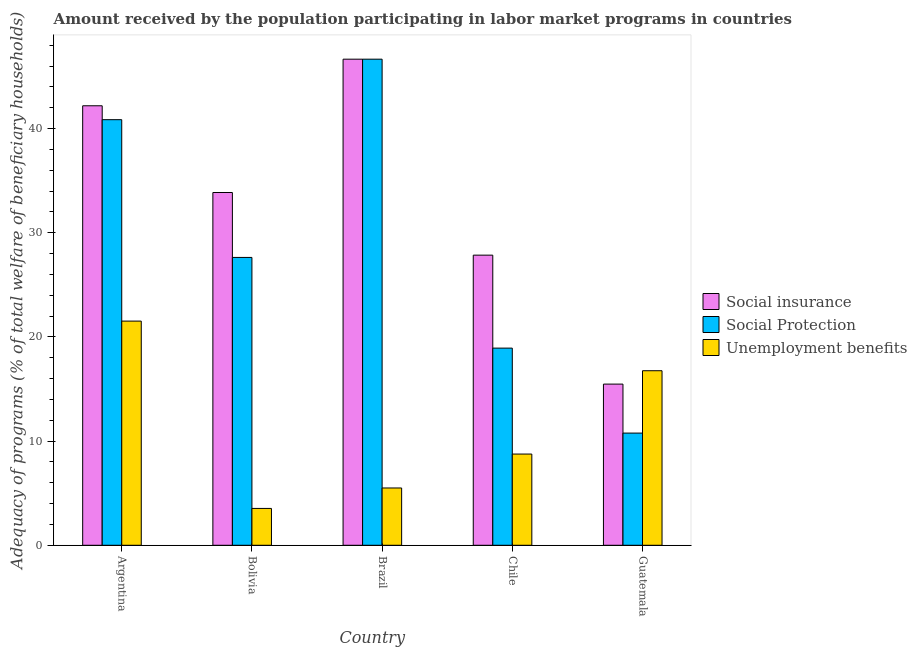How many different coloured bars are there?
Your answer should be compact. 3. How many groups of bars are there?
Your answer should be very brief. 5. Are the number of bars per tick equal to the number of legend labels?
Give a very brief answer. Yes. How many bars are there on the 2nd tick from the left?
Your answer should be very brief. 3. How many bars are there on the 3rd tick from the right?
Offer a terse response. 3. What is the label of the 4th group of bars from the left?
Offer a terse response. Chile. What is the amount received by the population participating in unemployment benefits programs in Bolivia?
Offer a terse response. 3.54. Across all countries, what is the maximum amount received by the population participating in unemployment benefits programs?
Provide a succinct answer. 21.52. Across all countries, what is the minimum amount received by the population participating in social insurance programs?
Your answer should be very brief. 15.47. In which country was the amount received by the population participating in social protection programs maximum?
Your response must be concise. Brazil. In which country was the amount received by the population participating in social protection programs minimum?
Your answer should be compact. Guatemala. What is the total amount received by the population participating in social protection programs in the graph?
Keep it short and to the point. 144.86. What is the difference between the amount received by the population participating in social insurance programs in Bolivia and that in Brazil?
Provide a short and direct response. -12.8. What is the difference between the amount received by the population participating in social protection programs in Brazil and the amount received by the population participating in unemployment benefits programs in Guatemala?
Offer a very short reply. 29.91. What is the average amount received by the population participating in social protection programs per country?
Provide a succinct answer. 28.97. What is the difference between the amount received by the population participating in social insurance programs and amount received by the population participating in social protection programs in Guatemala?
Give a very brief answer. 4.7. In how many countries, is the amount received by the population participating in unemployment benefits programs greater than 10 %?
Make the answer very short. 2. What is the ratio of the amount received by the population participating in social protection programs in Brazil to that in Chile?
Provide a short and direct response. 2.47. Is the difference between the amount received by the population participating in unemployment benefits programs in Chile and Guatemala greater than the difference between the amount received by the population participating in social insurance programs in Chile and Guatemala?
Give a very brief answer. No. What is the difference between the highest and the second highest amount received by the population participating in social insurance programs?
Your answer should be compact. 4.47. What is the difference between the highest and the lowest amount received by the population participating in social protection programs?
Provide a succinct answer. 35.9. Is the sum of the amount received by the population participating in unemployment benefits programs in Brazil and Chile greater than the maximum amount received by the population participating in social insurance programs across all countries?
Provide a succinct answer. No. What does the 3rd bar from the left in Guatemala represents?
Make the answer very short. Unemployment benefits. What does the 2nd bar from the right in Bolivia represents?
Your answer should be compact. Social Protection. Is it the case that in every country, the sum of the amount received by the population participating in social insurance programs and amount received by the population participating in social protection programs is greater than the amount received by the population participating in unemployment benefits programs?
Your response must be concise. Yes. Are all the bars in the graph horizontal?
Offer a terse response. No. What is the difference between two consecutive major ticks on the Y-axis?
Offer a very short reply. 10. Does the graph contain any zero values?
Offer a very short reply. No. How are the legend labels stacked?
Make the answer very short. Vertical. What is the title of the graph?
Offer a very short reply. Amount received by the population participating in labor market programs in countries. What is the label or title of the Y-axis?
Your response must be concise. Adequacy of programs (% of total welfare of beneficiary households). What is the Adequacy of programs (% of total welfare of beneficiary households) in Social insurance in Argentina?
Your answer should be very brief. 42.2. What is the Adequacy of programs (% of total welfare of beneficiary households) of Social Protection in Argentina?
Give a very brief answer. 40.86. What is the Adequacy of programs (% of total welfare of beneficiary households) in Unemployment benefits in Argentina?
Provide a succinct answer. 21.52. What is the Adequacy of programs (% of total welfare of beneficiary households) in Social insurance in Bolivia?
Provide a short and direct response. 33.87. What is the Adequacy of programs (% of total welfare of beneficiary households) of Social Protection in Bolivia?
Your answer should be compact. 27.63. What is the Adequacy of programs (% of total welfare of beneficiary households) of Unemployment benefits in Bolivia?
Your answer should be compact. 3.54. What is the Adequacy of programs (% of total welfare of beneficiary households) of Social insurance in Brazil?
Give a very brief answer. 46.67. What is the Adequacy of programs (% of total welfare of beneficiary households) in Social Protection in Brazil?
Give a very brief answer. 46.67. What is the Adequacy of programs (% of total welfare of beneficiary households) in Unemployment benefits in Brazil?
Your response must be concise. 5.5. What is the Adequacy of programs (% of total welfare of beneficiary households) of Social insurance in Chile?
Your answer should be very brief. 27.85. What is the Adequacy of programs (% of total welfare of beneficiary households) in Social Protection in Chile?
Keep it short and to the point. 18.93. What is the Adequacy of programs (% of total welfare of beneficiary households) of Unemployment benefits in Chile?
Your answer should be very brief. 8.76. What is the Adequacy of programs (% of total welfare of beneficiary households) in Social insurance in Guatemala?
Your answer should be very brief. 15.47. What is the Adequacy of programs (% of total welfare of beneficiary households) in Social Protection in Guatemala?
Keep it short and to the point. 10.77. What is the Adequacy of programs (% of total welfare of beneficiary households) of Unemployment benefits in Guatemala?
Keep it short and to the point. 16.76. Across all countries, what is the maximum Adequacy of programs (% of total welfare of beneficiary households) of Social insurance?
Offer a very short reply. 46.67. Across all countries, what is the maximum Adequacy of programs (% of total welfare of beneficiary households) of Social Protection?
Offer a terse response. 46.67. Across all countries, what is the maximum Adequacy of programs (% of total welfare of beneficiary households) in Unemployment benefits?
Give a very brief answer. 21.52. Across all countries, what is the minimum Adequacy of programs (% of total welfare of beneficiary households) of Social insurance?
Keep it short and to the point. 15.47. Across all countries, what is the minimum Adequacy of programs (% of total welfare of beneficiary households) of Social Protection?
Your answer should be compact. 10.77. Across all countries, what is the minimum Adequacy of programs (% of total welfare of beneficiary households) in Unemployment benefits?
Your response must be concise. 3.54. What is the total Adequacy of programs (% of total welfare of beneficiary households) in Social insurance in the graph?
Ensure brevity in your answer.  166.06. What is the total Adequacy of programs (% of total welfare of beneficiary households) in Social Protection in the graph?
Your answer should be compact. 144.86. What is the total Adequacy of programs (% of total welfare of beneficiary households) in Unemployment benefits in the graph?
Make the answer very short. 56.07. What is the difference between the Adequacy of programs (% of total welfare of beneficiary households) in Social insurance in Argentina and that in Bolivia?
Ensure brevity in your answer.  8.33. What is the difference between the Adequacy of programs (% of total welfare of beneficiary households) in Social Protection in Argentina and that in Bolivia?
Ensure brevity in your answer.  13.23. What is the difference between the Adequacy of programs (% of total welfare of beneficiary households) of Unemployment benefits in Argentina and that in Bolivia?
Give a very brief answer. 17.98. What is the difference between the Adequacy of programs (% of total welfare of beneficiary households) in Social insurance in Argentina and that in Brazil?
Provide a short and direct response. -4.47. What is the difference between the Adequacy of programs (% of total welfare of beneficiary households) of Social Protection in Argentina and that in Brazil?
Give a very brief answer. -5.81. What is the difference between the Adequacy of programs (% of total welfare of beneficiary households) in Unemployment benefits in Argentina and that in Brazil?
Provide a succinct answer. 16.02. What is the difference between the Adequacy of programs (% of total welfare of beneficiary households) of Social insurance in Argentina and that in Chile?
Give a very brief answer. 14.34. What is the difference between the Adequacy of programs (% of total welfare of beneficiary households) in Social Protection in Argentina and that in Chile?
Keep it short and to the point. 21.93. What is the difference between the Adequacy of programs (% of total welfare of beneficiary households) in Unemployment benefits in Argentina and that in Chile?
Keep it short and to the point. 12.76. What is the difference between the Adequacy of programs (% of total welfare of beneficiary households) of Social insurance in Argentina and that in Guatemala?
Offer a very short reply. 26.72. What is the difference between the Adequacy of programs (% of total welfare of beneficiary households) of Social Protection in Argentina and that in Guatemala?
Provide a short and direct response. 30.09. What is the difference between the Adequacy of programs (% of total welfare of beneficiary households) of Unemployment benefits in Argentina and that in Guatemala?
Ensure brevity in your answer.  4.76. What is the difference between the Adequacy of programs (% of total welfare of beneficiary households) in Social insurance in Bolivia and that in Brazil?
Keep it short and to the point. -12.8. What is the difference between the Adequacy of programs (% of total welfare of beneficiary households) in Social Protection in Bolivia and that in Brazil?
Your response must be concise. -19.03. What is the difference between the Adequacy of programs (% of total welfare of beneficiary households) of Unemployment benefits in Bolivia and that in Brazil?
Keep it short and to the point. -1.96. What is the difference between the Adequacy of programs (% of total welfare of beneficiary households) in Social insurance in Bolivia and that in Chile?
Keep it short and to the point. 6.01. What is the difference between the Adequacy of programs (% of total welfare of beneficiary households) of Social Protection in Bolivia and that in Chile?
Make the answer very short. 8.71. What is the difference between the Adequacy of programs (% of total welfare of beneficiary households) of Unemployment benefits in Bolivia and that in Chile?
Keep it short and to the point. -5.22. What is the difference between the Adequacy of programs (% of total welfare of beneficiary households) in Social insurance in Bolivia and that in Guatemala?
Provide a succinct answer. 18.39. What is the difference between the Adequacy of programs (% of total welfare of beneficiary households) in Social Protection in Bolivia and that in Guatemala?
Ensure brevity in your answer.  16.86. What is the difference between the Adequacy of programs (% of total welfare of beneficiary households) in Unemployment benefits in Bolivia and that in Guatemala?
Ensure brevity in your answer.  -13.22. What is the difference between the Adequacy of programs (% of total welfare of beneficiary households) of Social insurance in Brazil and that in Chile?
Your response must be concise. 18.81. What is the difference between the Adequacy of programs (% of total welfare of beneficiary households) of Social Protection in Brazil and that in Chile?
Provide a succinct answer. 27.74. What is the difference between the Adequacy of programs (% of total welfare of beneficiary households) of Unemployment benefits in Brazil and that in Chile?
Provide a short and direct response. -3.26. What is the difference between the Adequacy of programs (% of total welfare of beneficiary households) of Social insurance in Brazil and that in Guatemala?
Offer a terse response. 31.19. What is the difference between the Adequacy of programs (% of total welfare of beneficiary households) of Social Protection in Brazil and that in Guatemala?
Give a very brief answer. 35.9. What is the difference between the Adequacy of programs (% of total welfare of beneficiary households) of Unemployment benefits in Brazil and that in Guatemala?
Your answer should be compact. -11.26. What is the difference between the Adequacy of programs (% of total welfare of beneficiary households) of Social insurance in Chile and that in Guatemala?
Ensure brevity in your answer.  12.38. What is the difference between the Adequacy of programs (% of total welfare of beneficiary households) in Social Protection in Chile and that in Guatemala?
Provide a short and direct response. 8.16. What is the difference between the Adequacy of programs (% of total welfare of beneficiary households) of Unemployment benefits in Chile and that in Guatemala?
Give a very brief answer. -8. What is the difference between the Adequacy of programs (% of total welfare of beneficiary households) in Social insurance in Argentina and the Adequacy of programs (% of total welfare of beneficiary households) in Social Protection in Bolivia?
Your answer should be very brief. 14.56. What is the difference between the Adequacy of programs (% of total welfare of beneficiary households) in Social insurance in Argentina and the Adequacy of programs (% of total welfare of beneficiary households) in Unemployment benefits in Bolivia?
Give a very brief answer. 38.66. What is the difference between the Adequacy of programs (% of total welfare of beneficiary households) of Social Protection in Argentina and the Adequacy of programs (% of total welfare of beneficiary households) of Unemployment benefits in Bolivia?
Offer a terse response. 37.32. What is the difference between the Adequacy of programs (% of total welfare of beneficiary households) of Social insurance in Argentina and the Adequacy of programs (% of total welfare of beneficiary households) of Social Protection in Brazil?
Your response must be concise. -4.47. What is the difference between the Adequacy of programs (% of total welfare of beneficiary households) of Social insurance in Argentina and the Adequacy of programs (% of total welfare of beneficiary households) of Unemployment benefits in Brazil?
Keep it short and to the point. 36.69. What is the difference between the Adequacy of programs (% of total welfare of beneficiary households) in Social Protection in Argentina and the Adequacy of programs (% of total welfare of beneficiary households) in Unemployment benefits in Brazil?
Give a very brief answer. 35.36. What is the difference between the Adequacy of programs (% of total welfare of beneficiary households) in Social insurance in Argentina and the Adequacy of programs (% of total welfare of beneficiary households) in Social Protection in Chile?
Offer a terse response. 23.27. What is the difference between the Adequacy of programs (% of total welfare of beneficiary households) in Social insurance in Argentina and the Adequacy of programs (% of total welfare of beneficiary households) in Unemployment benefits in Chile?
Provide a short and direct response. 33.44. What is the difference between the Adequacy of programs (% of total welfare of beneficiary households) in Social Protection in Argentina and the Adequacy of programs (% of total welfare of beneficiary households) in Unemployment benefits in Chile?
Offer a very short reply. 32.1. What is the difference between the Adequacy of programs (% of total welfare of beneficiary households) of Social insurance in Argentina and the Adequacy of programs (% of total welfare of beneficiary households) of Social Protection in Guatemala?
Keep it short and to the point. 31.42. What is the difference between the Adequacy of programs (% of total welfare of beneficiary households) of Social insurance in Argentina and the Adequacy of programs (% of total welfare of beneficiary households) of Unemployment benefits in Guatemala?
Make the answer very short. 25.44. What is the difference between the Adequacy of programs (% of total welfare of beneficiary households) of Social Protection in Argentina and the Adequacy of programs (% of total welfare of beneficiary households) of Unemployment benefits in Guatemala?
Provide a short and direct response. 24.1. What is the difference between the Adequacy of programs (% of total welfare of beneficiary households) in Social insurance in Bolivia and the Adequacy of programs (% of total welfare of beneficiary households) in Social Protection in Brazil?
Ensure brevity in your answer.  -12.8. What is the difference between the Adequacy of programs (% of total welfare of beneficiary households) in Social insurance in Bolivia and the Adequacy of programs (% of total welfare of beneficiary households) in Unemployment benefits in Brazil?
Make the answer very short. 28.37. What is the difference between the Adequacy of programs (% of total welfare of beneficiary households) of Social Protection in Bolivia and the Adequacy of programs (% of total welfare of beneficiary households) of Unemployment benefits in Brazil?
Offer a very short reply. 22.13. What is the difference between the Adequacy of programs (% of total welfare of beneficiary households) in Social insurance in Bolivia and the Adequacy of programs (% of total welfare of beneficiary households) in Social Protection in Chile?
Keep it short and to the point. 14.94. What is the difference between the Adequacy of programs (% of total welfare of beneficiary households) of Social insurance in Bolivia and the Adequacy of programs (% of total welfare of beneficiary households) of Unemployment benefits in Chile?
Your answer should be compact. 25.11. What is the difference between the Adequacy of programs (% of total welfare of beneficiary households) of Social Protection in Bolivia and the Adequacy of programs (% of total welfare of beneficiary households) of Unemployment benefits in Chile?
Make the answer very short. 18.88. What is the difference between the Adequacy of programs (% of total welfare of beneficiary households) in Social insurance in Bolivia and the Adequacy of programs (% of total welfare of beneficiary households) in Social Protection in Guatemala?
Provide a succinct answer. 23.1. What is the difference between the Adequacy of programs (% of total welfare of beneficiary households) in Social insurance in Bolivia and the Adequacy of programs (% of total welfare of beneficiary households) in Unemployment benefits in Guatemala?
Keep it short and to the point. 17.11. What is the difference between the Adequacy of programs (% of total welfare of beneficiary households) of Social Protection in Bolivia and the Adequacy of programs (% of total welfare of beneficiary households) of Unemployment benefits in Guatemala?
Make the answer very short. 10.88. What is the difference between the Adequacy of programs (% of total welfare of beneficiary households) of Social insurance in Brazil and the Adequacy of programs (% of total welfare of beneficiary households) of Social Protection in Chile?
Provide a succinct answer. 27.74. What is the difference between the Adequacy of programs (% of total welfare of beneficiary households) in Social insurance in Brazil and the Adequacy of programs (% of total welfare of beneficiary households) in Unemployment benefits in Chile?
Your answer should be compact. 37.91. What is the difference between the Adequacy of programs (% of total welfare of beneficiary households) of Social Protection in Brazil and the Adequacy of programs (% of total welfare of beneficiary households) of Unemployment benefits in Chile?
Give a very brief answer. 37.91. What is the difference between the Adequacy of programs (% of total welfare of beneficiary households) in Social insurance in Brazil and the Adequacy of programs (% of total welfare of beneficiary households) in Social Protection in Guatemala?
Ensure brevity in your answer.  35.9. What is the difference between the Adequacy of programs (% of total welfare of beneficiary households) of Social insurance in Brazil and the Adequacy of programs (% of total welfare of beneficiary households) of Unemployment benefits in Guatemala?
Offer a very short reply. 29.91. What is the difference between the Adequacy of programs (% of total welfare of beneficiary households) of Social Protection in Brazil and the Adequacy of programs (% of total welfare of beneficiary households) of Unemployment benefits in Guatemala?
Your answer should be very brief. 29.91. What is the difference between the Adequacy of programs (% of total welfare of beneficiary households) in Social insurance in Chile and the Adequacy of programs (% of total welfare of beneficiary households) in Social Protection in Guatemala?
Make the answer very short. 17.08. What is the difference between the Adequacy of programs (% of total welfare of beneficiary households) in Social insurance in Chile and the Adequacy of programs (% of total welfare of beneficiary households) in Unemployment benefits in Guatemala?
Provide a short and direct response. 11.1. What is the difference between the Adequacy of programs (% of total welfare of beneficiary households) of Social Protection in Chile and the Adequacy of programs (% of total welfare of beneficiary households) of Unemployment benefits in Guatemala?
Ensure brevity in your answer.  2.17. What is the average Adequacy of programs (% of total welfare of beneficiary households) in Social insurance per country?
Give a very brief answer. 33.21. What is the average Adequacy of programs (% of total welfare of beneficiary households) of Social Protection per country?
Provide a succinct answer. 28.97. What is the average Adequacy of programs (% of total welfare of beneficiary households) of Unemployment benefits per country?
Offer a very short reply. 11.21. What is the difference between the Adequacy of programs (% of total welfare of beneficiary households) in Social insurance and Adequacy of programs (% of total welfare of beneficiary households) in Social Protection in Argentina?
Offer a terse response. 1.33. What is the difference between the Adequacy of programs (% of total welfare of beneficiary households) of Social insurance and Adequacy of programs (% of total welfare of beneficiary households) of Unemployment benefits in Argentina?
Offer a terse response. 20.67. What is the difference between the Adequacy of programs (% of total welfare of beneficiary households) in Social Protection and Adequacy of programs (% of total welfare of beneficiary households) in Unemployment benefits in Argentina?
Your response must be concise. 19.34. What is the difference between the Adequacy of programs (% of total welfare of beneficiary households) in Social insurance and Adequacy of programs (% of total welfare of beneficiary households) in Social Protection in Bolivia?
Keep it short and to the point. 6.23. What is the difference between the Adequacy of programs (% of total welfare of beneficiary households) in Social insurance and Adequacy of programs (% of total welfare of beneficiary households) in Unemployment benefits in Bolivia?
Give a very brief answer. 30.33. What is the difference between the Adequacy of programs (% of total welfare of beneficiary households) in Social Protection and Adequacy of programs (% of total welfare of beneficiary households) in Unemployment benefits in Bolivia?
Keep it short and to the point. 24.1. What is the difference between the Adequacy of programs (% of total welfare of beneficiary households) in Social insurance and Adequacy of programs (% of total welfare of beneficiary households) in Unemployment benefits in Brazil?
Your response must be concise. 41.17. What is the difference between the Adequacy of programs (% of total welfare of beneficiary households) in Social Protection and Adequacy of programs (% of total welfare of beneficiary households) in Unemployment benefits in Brazil?
Your answer should be very brief. 41.17. What is the difference between the Adequacy of programs (% of total welfare of beneficiary households) of Social insurance and Adequacy of programs (% of total welfare of beneficiary households) of Social Protection in Chile?
Your answer should be compact. 8.93. What is the difference between the Adequacy of programs (% of total welfare of beneficiary households) of Social insurance and Adequacy of programs (% of total welfare of beneficiary households) of Unemployment benefits in Chile?
Provide a short and direct response. 19.1. What is the difference between the Adequacy of programs (% of total welfare of beneficiary households) of Social Protection and Adequacy of programs (% of total welfare of beneficiary households) of Unemployment benefits in Chile?
Give a very brief answer. 10.17. What is the difference between the Adequacy of programs (% of total welfare of beneficiary households) in Social insurance and Adequacy of programs (% of total welfare of beneficiary households) in Social Protection in Guatemala?
Your response must be concise. 4.7. What is the difference between the Adequacy of programs (% of total welfare of beneficiary households) of Social insurance and Adequacy of programs (% of total welfare of beneficiary households) of Unemployment benefits in Guatemala?
Make the answer very short. -1.28. What is the difference between the Adequacy of programs (% of total welfare of beneficiary households) in Social Protection and Adequacy of programs (% of total welfare of beneficiary households) in Unemployment benefits in Guatemala?
Provide a short and direct response. -5.99. What is the ratio of the Adequacy of programs (% of total welfare of beneficiary households) in Social insurance in Argentina to that in Bolivia?
Offer a terse response. 1.25. What is the ratio of the Adequacy of programs (% of total welfare of beneficiary households) of Social Protection in Argentina to that in Bolivia?
Provide a short and direct response. 1.48. What is the ratio of the Adequacy of programs (% of total welfare of beneficiary households) in Unemployment benefits in Argentina to that in Bolivia?
Provide a short and direct response. 6.08. What is the ratio of the Adequacy of programs (% of total welfare of beneficiary households) of Social insurance in Argentina to that in Brazil?
Provide a short and direct response. 0.9. What is the ratio of the Adequacy of programs (% of total welfare of beneficiary households) of Social Protection in Argentina to that in Brazil?
Keep it short and to the point. 0.88. What is the ratio of the Adequacy of programs (% of total welfare of beneficiary households) in Unemployment benefits in Argentina to that in Brazil?
Provide a short and direct response. 3.91. What is the ratio of the Adequacy of programs (% of total welfare of beneficiary households) of Social insurance in Argentina to that in Chile?
Your response must be concise. 1.51. What is the ratio of the Adequacy of programs (% of total welfare of beneficiary households) in Social Protection in Argentina to that in Chile?
Provide a succinct answer. 2.16. What is the ratio of the Adequacy of programs (% of total welfare of beneficiary households) in Unemployment benefits in Argentina to that in Chile?
Ensure brevity in your answer.  2.46. What is the ratio of the Adequacy of programs (% of total welfare of beneficiary households) in Social insurance in Argentina to that in Guatemala?
Your answer should be very brief. 2.73. What is the ratio of the Adequacy of programs (% of total welfare of beneficiary households) in Social Protection in Argentina to that in Guatemala?
Your answer should be very brief. 3.79. What is the ratio of the Adequacy of programs (% of total welfare of beneficiary households) in Unemployment benefits in Argentina to that in Guatemala?
Keep it short and to the point. 1.28. What is the ratio of the Adequacy of programs (% of total welfare of beneficiary households) in Social insurance in Bolivia to that in Brazil?
Give a very brief answer. 0.73. What is the ratio of the Adequacy of programs (% of total welfare of beneficiary households) in Social Protection in Bolivia to that in Brazil?
Offer a very short reply. 0.59. What is the ratio of the Adequacy of programs (% of total welfare of beneficiary households) in Unemployment benefits in Bolivia to that in Brazil?
Keep it short and to the point. 0.64. What is the ratio of the Adequacy of programs (% of total welfare of beneficiary households) of Social insurance in Bolivia to that in Chile?
Ensure brevity in your answer.  1.22. What is the ratio of the Adequacy of programs (% of total welfare of beneficiary households) in Social Protection in Bolivia to that in Chile?
Offer a terse response. 1.46. What is the ratio of the Adequacy of programs (% of total welfare of beneficiary households) in Unemployment benefits in Bolivia to that in Chile?
Your answer should be compact. 0.4. What is the ratio of the Adequacy of programs (% of total welfare of beneficiary households) in Social insurance in Bolivia to that in Guatemala?
Your response must be concise. 2.19. What is the ratio of the Adequacy of programs (% of total welfare of beneficiary households) in Social Protection in Bolivia to that in Guatemala?
Provide a short and direct response. 2.57. What is the ratio of the Adequacy of programs (% of total welfare of beneficiary households) in Unemployment benefits in Bolivia to that in Guatemala?
Your response must be concise. 0.21. What is the ratio of the Adequacy of programs (% of total welfare of beneficiary households) in Social insurance in Brazil to that in Chile?
Make the answer very short. 1.68. What is the ratio of the Adequacy of programs (% of total welfare of beneficiary households) of Social Protection in Brazil to that in Chile?
Your answer should be compact. 2.47. What is the ratio of the Adequacy of programs (% of total welfare of beneficiary households) of Unemployment benefits in Brazil to that in Chile?
Give a very brief answer. 0.63. What is the ratio of the Adequacy of programs (% of total welfare of beneficiary households) in Social insurance in Brazil to that in Guatemala?
Ensure brevity in your answer.  3.02. What is the ratio of the Adequacy of programs (% of total welfare of beneficiary households) in Social Protection in Brazil to that in Guatemala?
Offer a very short reply. 4.33. What is the ratio of the Adequacy of programs (% of total welfare of beneficiary households) in Unemployment benefits in Brazil to that in Guatemala?
Your answer should be very brief. 0.33. What is the ratio of the Adequacy of programs (% of total welfare of beneficiary households) of Social insurance in Chile to that in Guatemala?
Provide a short and direct response. 1.8. What is the ratio of the Adequacy of programs (% of total welfare of beneficiary households) of Social Protection in Chile to that in Guatemala?
Your answer should be compact. 1.76. What is the ratio of the Adequacy of programs (% of total welfare of beneficiary households) in Unemployment benefits in Chile to that in Guatemala?
Your answer should be very brief. 0.52. What is the difference between the highest and the second highest Adequacy of programs (% of total welfare of beneficiary households) of Social insurance?
Offer a very short reply. 4.47. What is the difference between the highest and the second highest Adequacy of programs (% of total welfare of beneficiary households) in Social Protection?
Your answer should be compact. 5.81. What is the difference between the highest and the second highest Adequacy of programs (% of total welfare of beneficiary households) in Unemployment benefits?
Your answer should be compact. 4.76. What is the difference between the highest and the lowest Adequacy of programs (% of total welfare of beneficiary households) of Social insurance?
Give a very brief answer. 31.19. What is the difference between the highest and the lowest Adequacy of programs (% of total welfare of beneficiary households) of Social Protection?
Keep it short and to the point. 35.9. What is the difference between the highest and the lowest Adequacy of programs (% of total welfare of beneficiary households) of Unemployment benefits?
Ensure brevity in your answer.  17.98. 